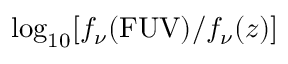Convert formula to latex. <formula><loc_0><loc_0><loc_500><loc_500>\log _ { 1 0 } [ f _ { \nu } ( F U V ) / f _ { \nu } ( z ) ]</formula> 